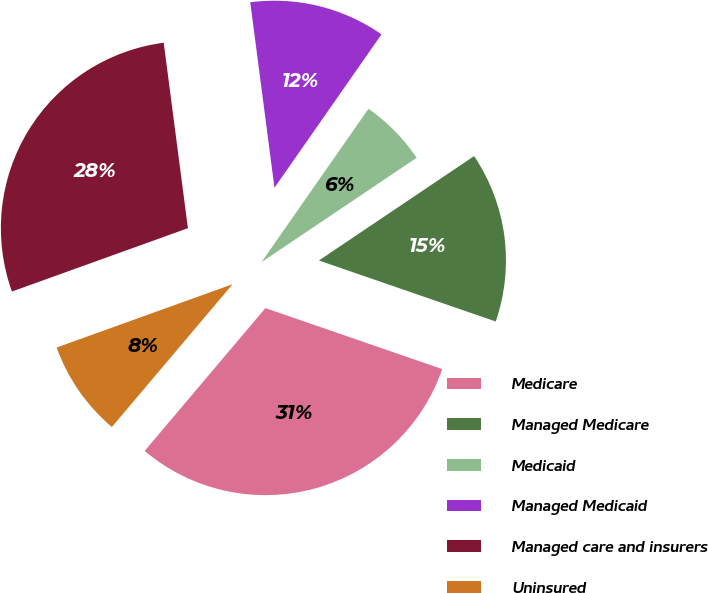Convert chart. <chart><loc_0><loc_0><loc_500><loc_500><pie_chart><fcel>Medicare<fcel>Managed Medicare<fcel>Medicaid<fcel>Managed Medicaid<fcel>Managed care and insurers<fcel>Uninsured<nl><fcel>30.88%<fcel>14.71%<fcel>5.88%<fcel>11.76%<fcel>28.43%<fcel>8.33%<nl></chart> 